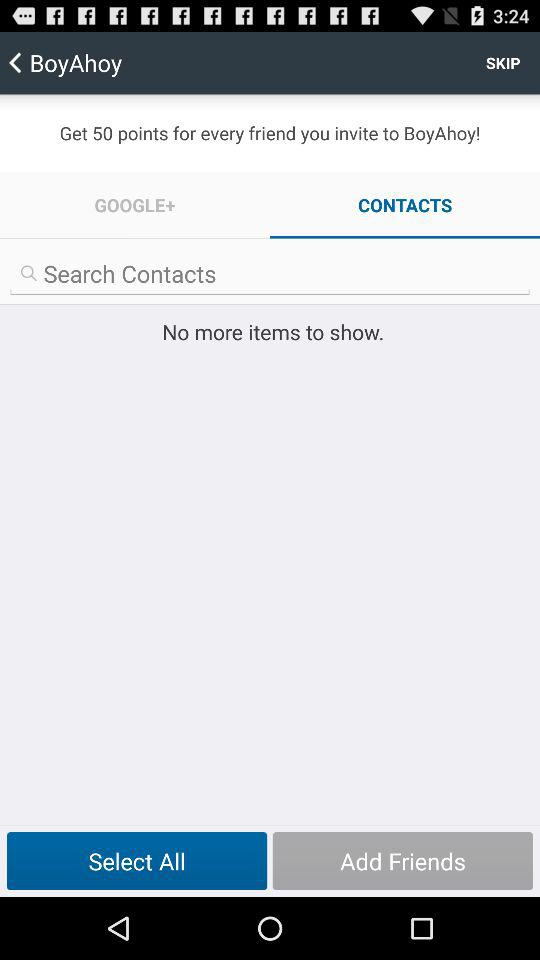Which tab is selected? The selected tab is "CONTACTS". 